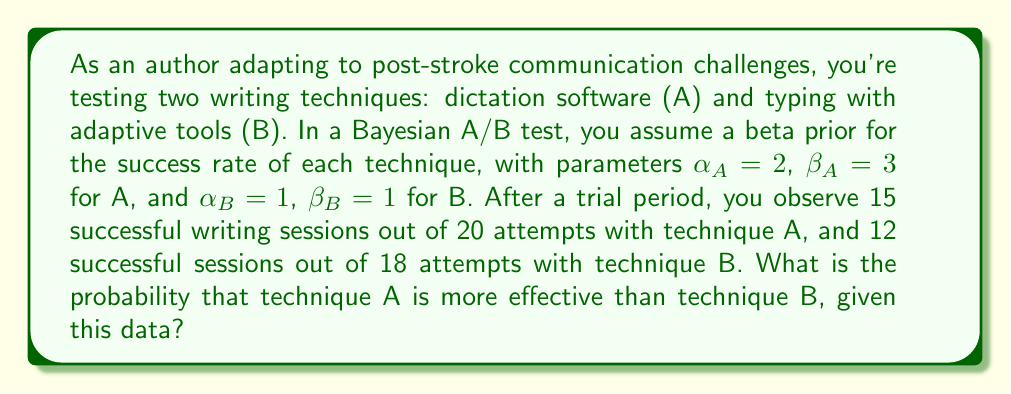Help me with this question. To solve this problem, we'll use Bayesian A/B testing with beta distributions. Let's break it down step-by-step:

1) First, we need to calculate the posterior distributions for both techniques:

   For technique A: 
   Prior: Beta($\alpha_A = 2$, $\beta_A = 3$)
   Data: 15 successes out of 20 attempts
   Posterior: Beta($\alpha_A + 15$, $\beta_A + 5$) = Beta(17, 8)

   For technique B:
   Prior: Beta($\alpha_B = 1$, $\beta_B = 1$)
   Data: 12 successes out of 18 attempts
   Posterior: Beta($\alpha_B + 12$, $\beta_B + 6$) = Beta(13, 7)

2) Now, we need to calculate the probability that technique A is more effective than B. This is equivalent to calculating P(θ_A > θ_B), where θ_A and θ_B are random variables from the posterior distributions of A and B respectively.

3) For beta distributions, this probability can be calculated using the following formula:

   $$P(\theta_A > \theta_B) = \int_0^1 P(\theta_A > \theta_B | \theta_B) \cdot P(\theta_B) d\theta_B$$

4) This integral doesn't have a closed-form solution, but it can be approximated numerically. One efficient method is to use the beta function:

   $$P(\theta_A > \theta_B) = \sum_{i=0}^{\alpha_B-1} \frac{B(\alpha_A+i, \beta_A+\beta_B)}{(\beta_B+i) \cdot B(\alpha_A, \beta_A) \cdot B(\alpha_B, \beta_B)} \cdot \binom{\alpha_B+\beta_B-1}{i}$$

   Where B(a,b) is the beta function.

5) Plugging in our values:
   $\alpha_A = 17$, $\beta_A = 8$, $\alpha_B = 13$, $\beta_B = 7$

6) Calculating this (which would typically be done with a computer due to the complexity):

   $$P(\theta_A > \theta_B) \approx 0.7301$$

Therefore, the probability that technique A (dictation software) is more effective than technique B (typing with adaptive tools) is approximately 0.7301 or 73.01%.
Answer: 0.7301 (or 73.01%) 